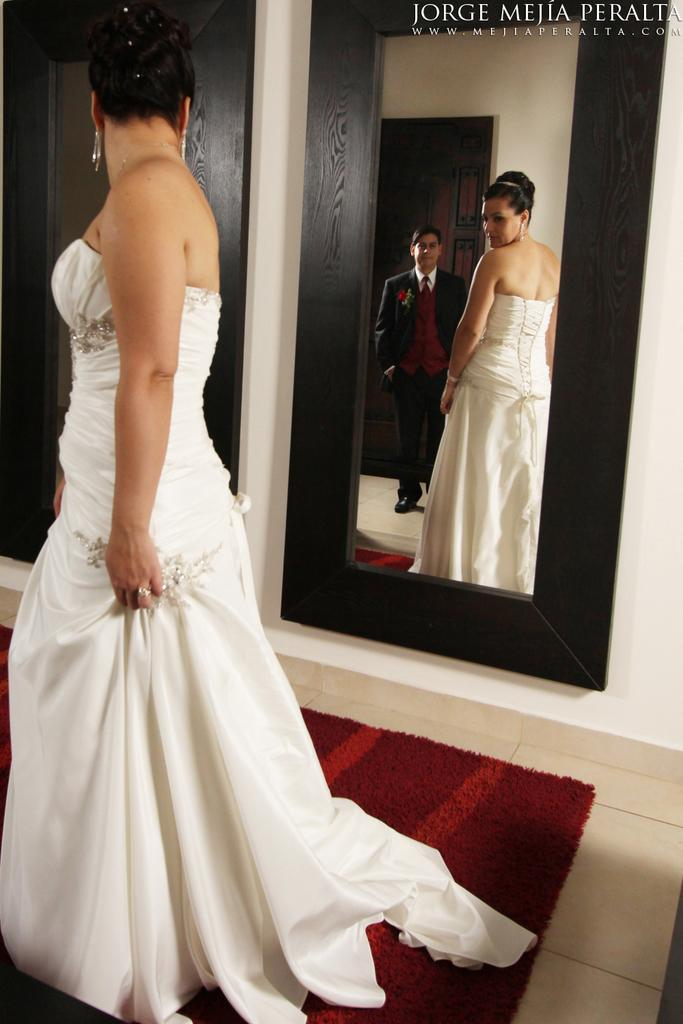Who is present in the image? There is a woman and a man in the image. What is the woman doing in the image? The woman is standing near a mirror in the image. What is the man wearing in the image? The man is wearing a suit in the image. What type of flooring is visible in the image? There is a red color carpet in the image. What is the purpose of the holiday being celebrated in the image? There is no indication of a holiday being celebrated in the image. The image only shows a woman standing near a mirror and a man wearing a suit on a red carpet. 